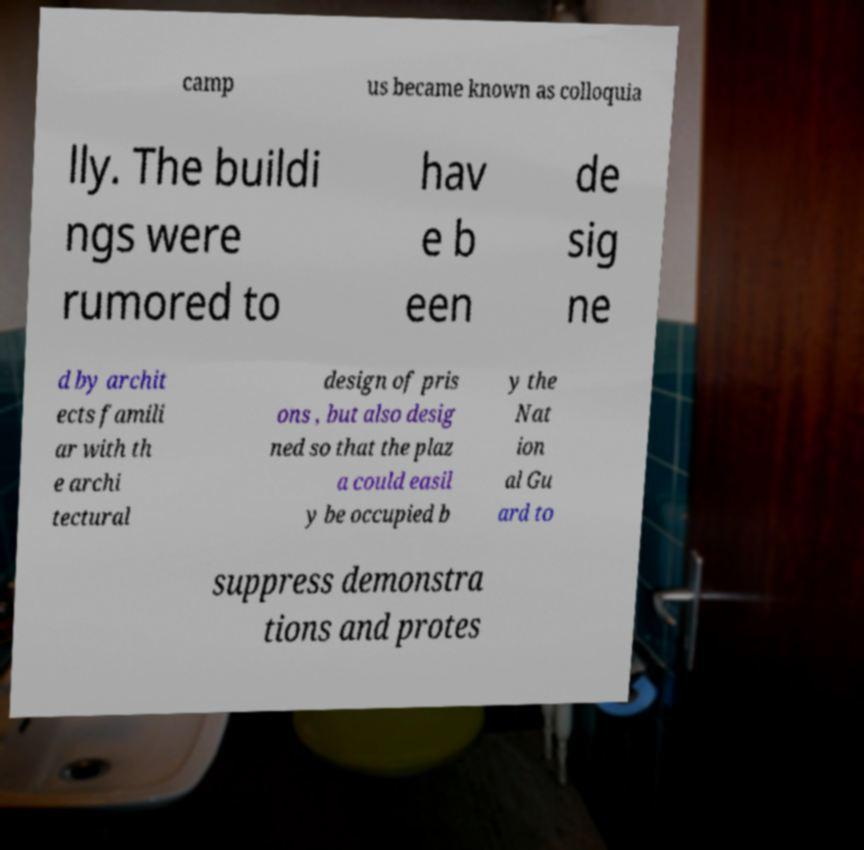Could you extract and type out the text from this image? camp us became known as colloquia lly. The buildi ngs were rumored to hav e b een de sig ne d by archit ects famili ar with th e archi tectural design of pris ons , but also desig ned so that the plaz a could easil y be occupied b y the Nat ion al Gu ard to suppress demonstra tions and protes 